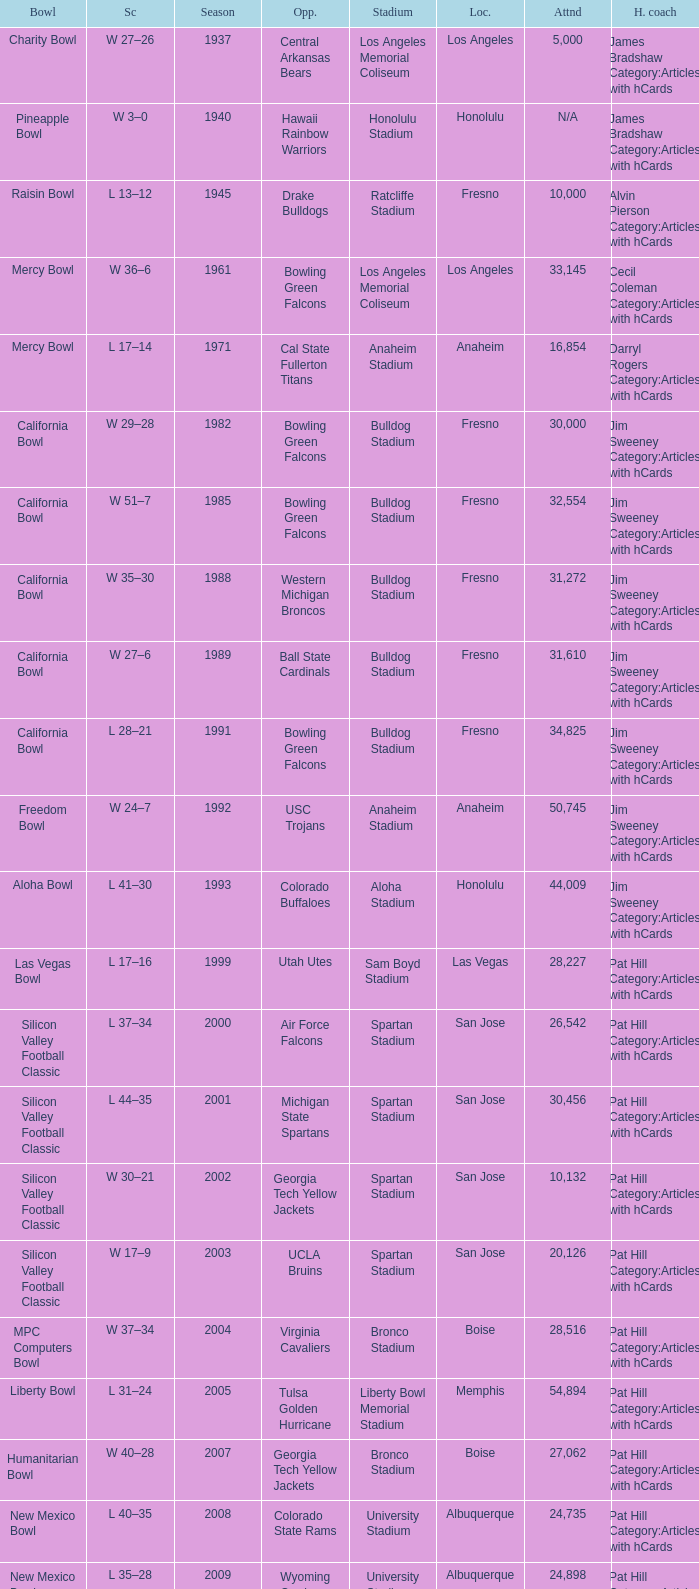What stadium had an opponent of Cal State Fullerton Titans? Anaheim Stadium. 